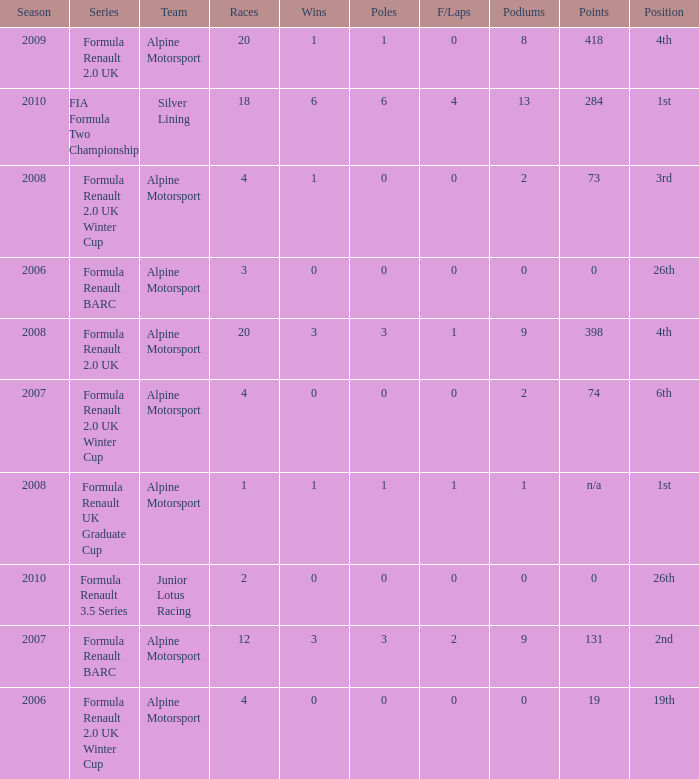What was the earliest season where podium was 9? 2007.0. 